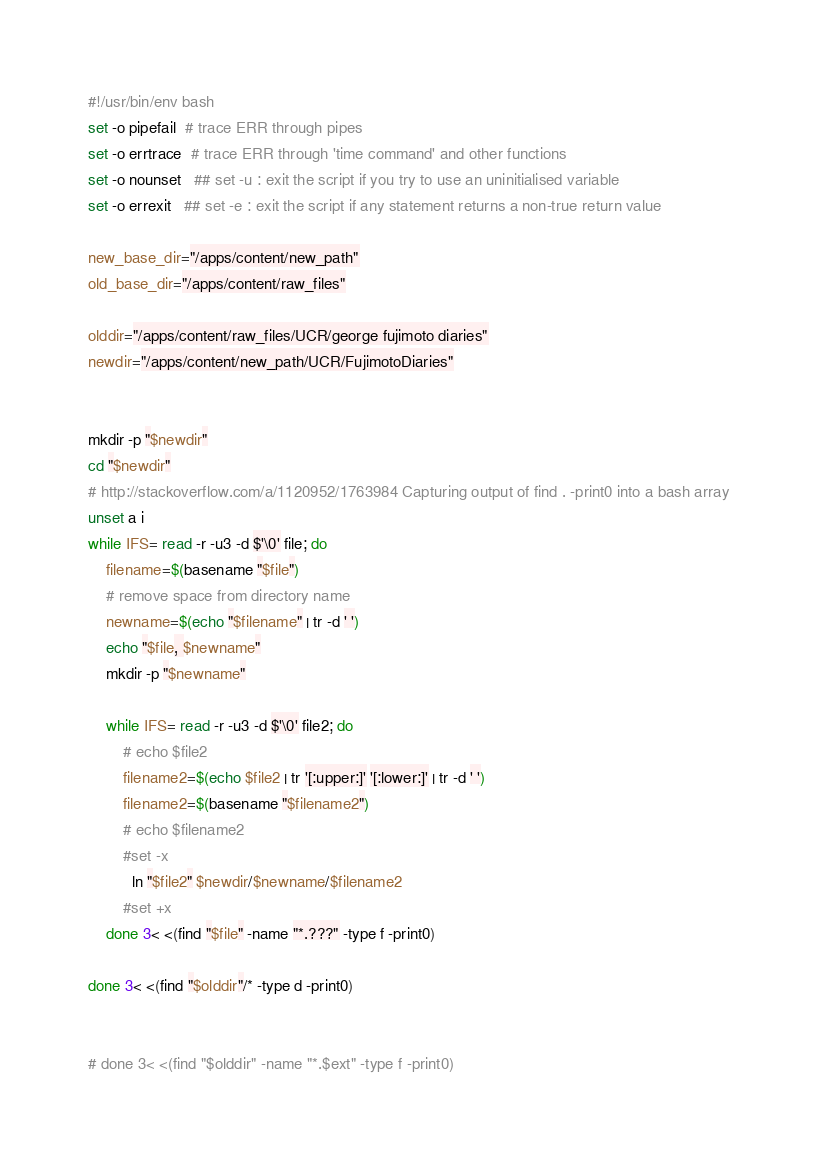<code> <loc_0><loc_0><loc_500><loc_500><_Bash_>#!/usr/bin/env bash
set -o pipefail  # trace ERR through pipes
set -o errtrace  # trace ERR through 'time command' and other functions
set -o nounset   ## set -u : exit the script if you try to use an uninitialised variable
set -o errexit   ## set -e : exit the script if any statement returns a non-true return value

new_base_dir="/apps/content/new_path"
old_base_dir="/apps/content/raw_files"

olddir="/apps/content/raw_files/UCR/george fujimoto diaries"
newdir="/apps/content/new_path/UCR/FujimotoDiaries"


mkdir -p "$newdir"
cd "$newdir"
# http://stackoverflow.com/a/1120952/1763984 Capturing output of find . -print0 into a bash array
unset a i
while IFS= read -r -u3 -d $'\0' file; do
    filename=$(basename "$file")
    # remove space from directory name
    newname=$(echo "$filename" | tr -d ' ')
    echo "$file, $newname"
    mkdir -p "$newname"

    while IFS= read -r -u3 -d $'\0' file2; do
        # echo $file2
        filename2=$(echo $file2 | tr '[:upper:]' '[:lower:]' | tr -d ' ')
        filename2=$(basename "$filename2")
        # echo $filename2
        #set -x
          ln "$file2" $newdir/$newname/$filename2
        #set +x
    done 3< <(find "$file" -name "*.???" -type f -print0)

done 3< <(find "$olddir"/* -type d -print0)


# done 3< <(find "$olddir" -name "*.$ext" -type f -print0)

</code> 